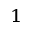Convert formula to latex. <formula><loc_0><loc_0><loc_500><loc_500>^ { 1 }</formula> 